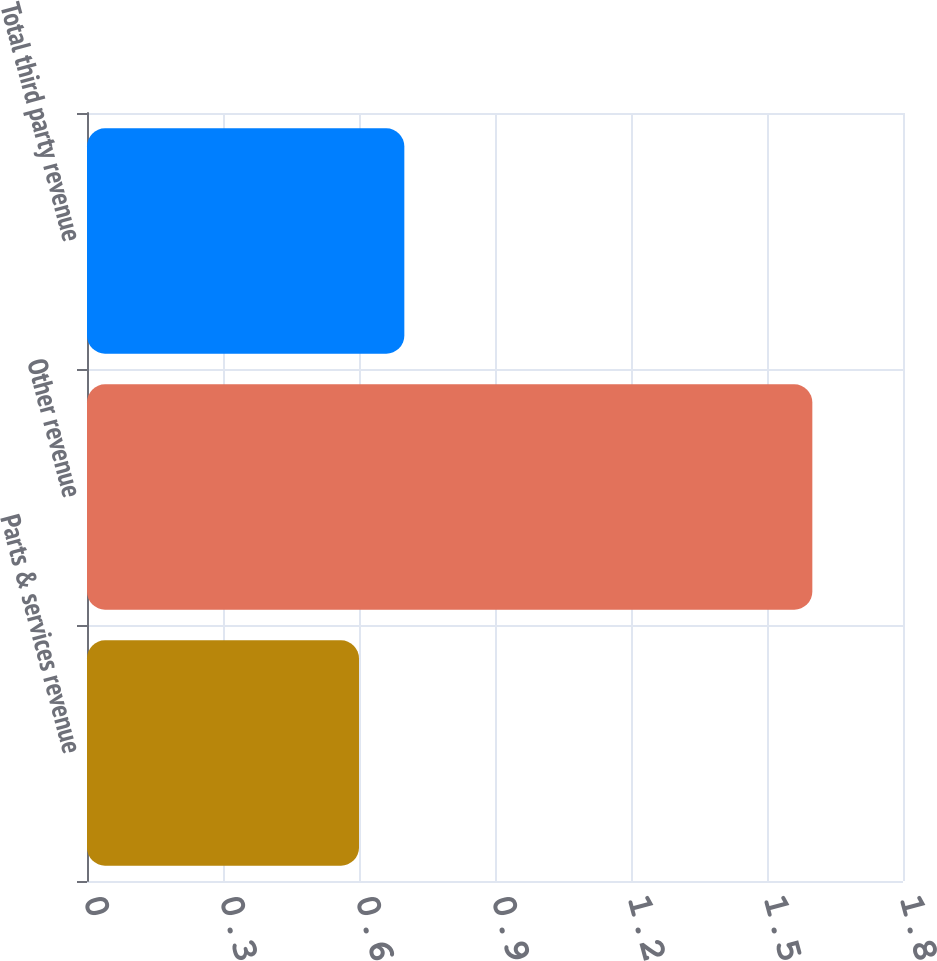<chart> <loc_0><loc_0><loc_500><loc_500><bar_chart><fcel>Parts & services revenue<fcel>Other revenue<fcel>Total third party revenue<nl><fcel>0.6<fcel>1.6<fcel>0.7<nl></chart> 